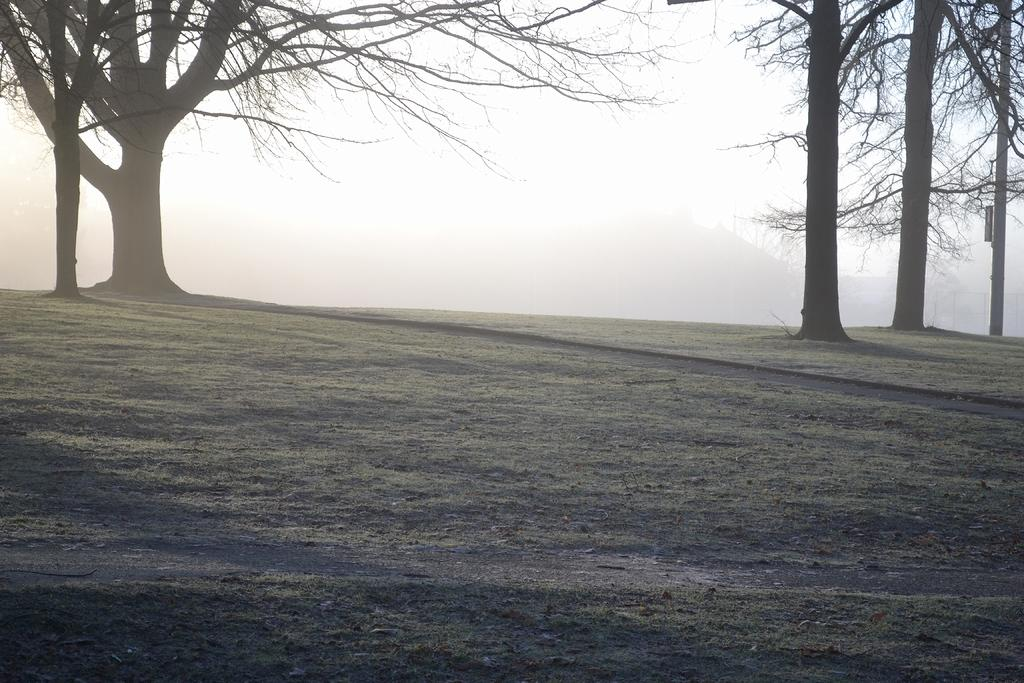What type of vegetation can be seen in the image? There are trees in the image. What part of the natural environment is visible at the bottom of the image? The ground is visible at the bottom of the image. What part of the natural environment is visible at the top of the image? The sky is visible at the top of the image. Where are the dolls placed in the image? There are no dolls present in the image. What type of bomb can be seen in the image? There is no bomb present in the image. 